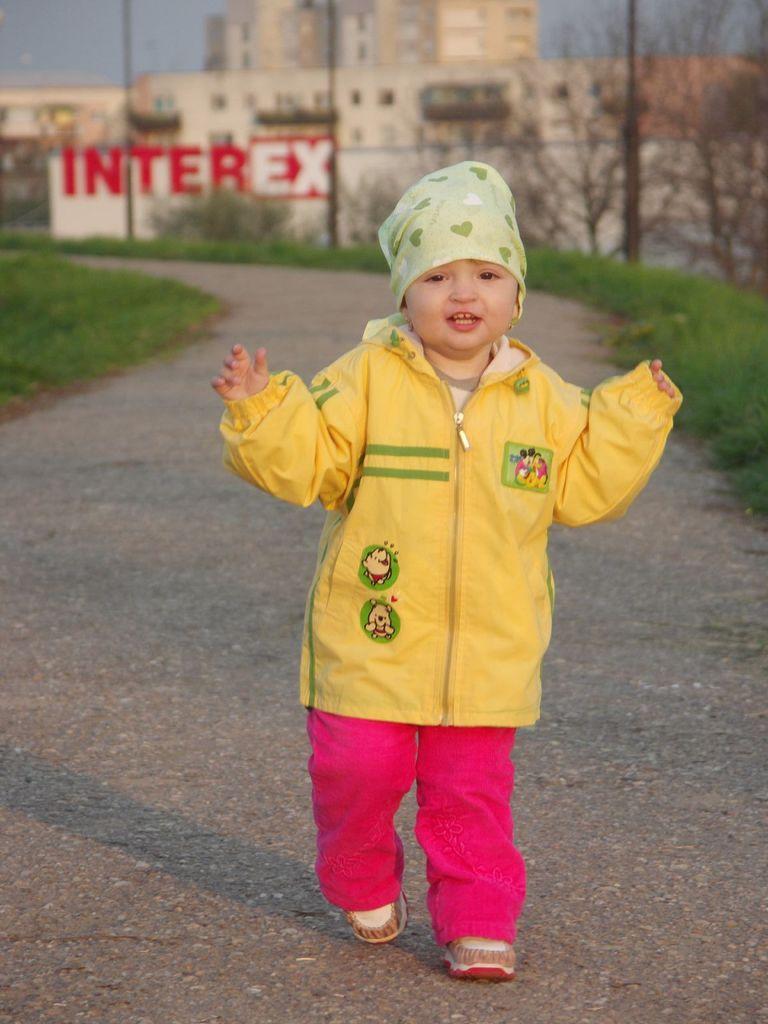How would you summarize this image in a sentence or two? In this image, I can see a kid standing on the pathway. On the left and right side of the image, I can see the grass. In the background, these are the buildings, trees and a name board. 